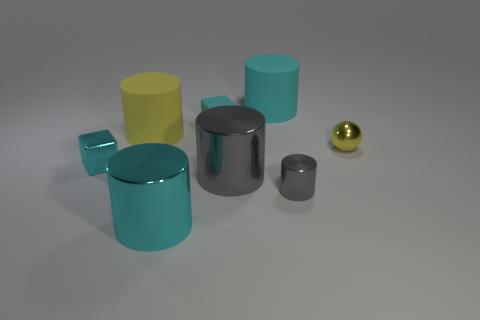There is a cyan cylinder that is in front of the big yellow matte thing; is its size the same as the gray object behind the small gray shiny object?
Make the answer very short. Yes. How many other things are made of the same material as the big gray cylinder?
Your answer should be very brief. 4. Is the number of small balls behind the yellow metallic object greater than the number of tiny gray objects behind the yellow cylinder?
Provide a succinct answer. No. There is a big cyan cylinder that is in front of the big gray metal cylinder; what is its material?
Offer a very short reply. Metal. Is the shape of the yellow shiny thing the same as the tiny rubber thing?
Keep it short and to the point. No. Are there any other things that are the same color as the tiny metal cylinder?
Your answer should be compact. Yes. There is a small thing that is the same shape as the large yellow object; what color is it?
Offer a terse response. Gray. Is the number of yellow metal objects that are left of the tiny yellow thing greater than the number of objects?
Give a very brief answer. No. There is a matte cylinder right of the big yellow cylinder; what color is it?
Provide a short and direct response. Cyan. Do the cyan matte block and the yellow cylinder have the same size?
Your answer should be compact. No. 